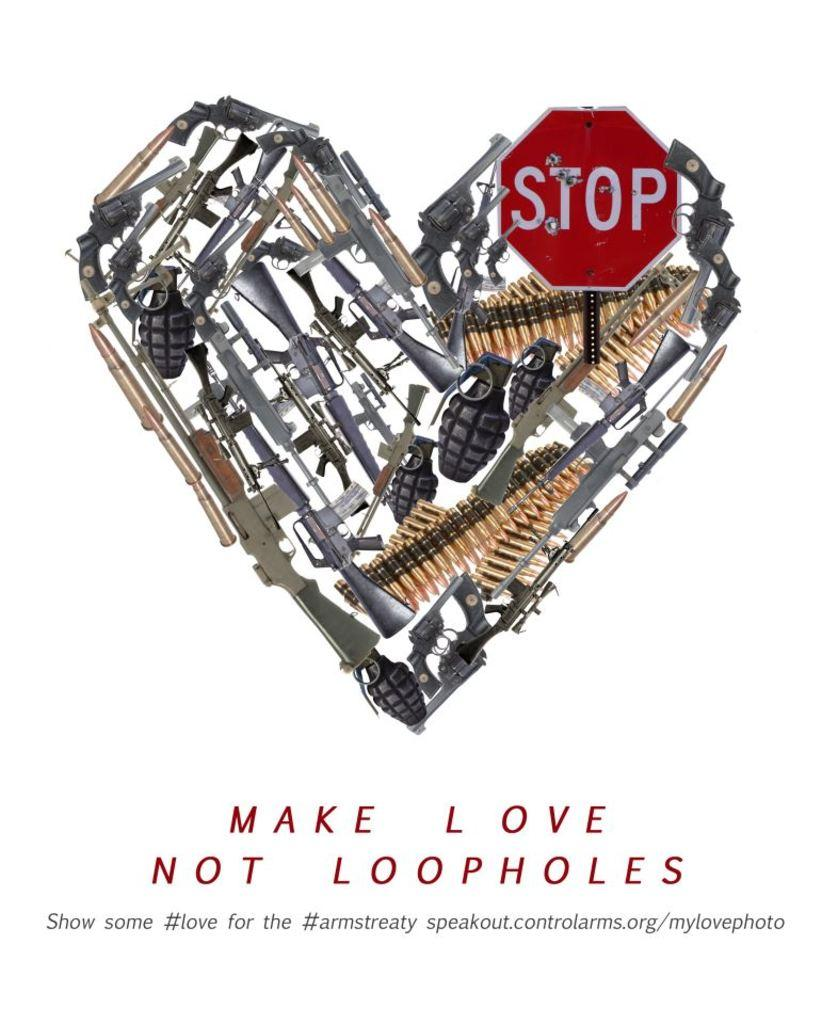<image>
Provide a brief description of the given image. book with a heart on the cover called make love not loopholes 